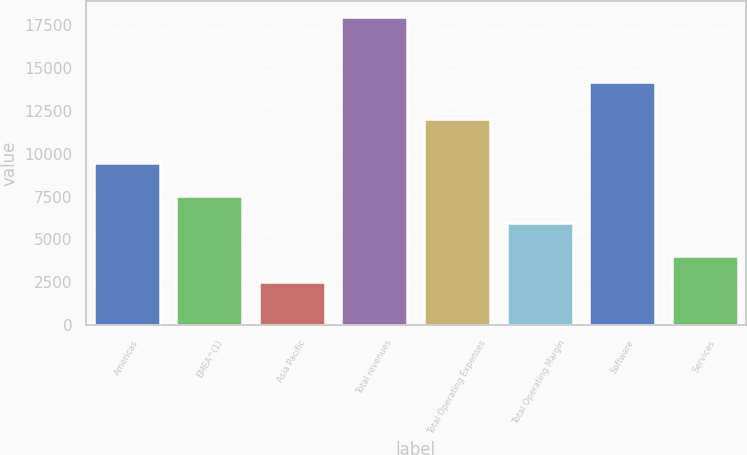Convert chart to OTSL. <chart><loc_0><loc_0><loc_500><loc_500><bar_chart><fcel>Americas<fcel>EMEA^(1)<fcel>Asia Pacific<fcel>Total revenues<fcel>Total Operating Expenses<fcel>Total Operating Margin<fcel>Software<fcel>Services<nl><fcel>9460<fcel>7523.7<fcel>2499<fcel>17996<fcel>12022<fcel>5974<fcel>14211<fcel>4048.7<nl></chart> 